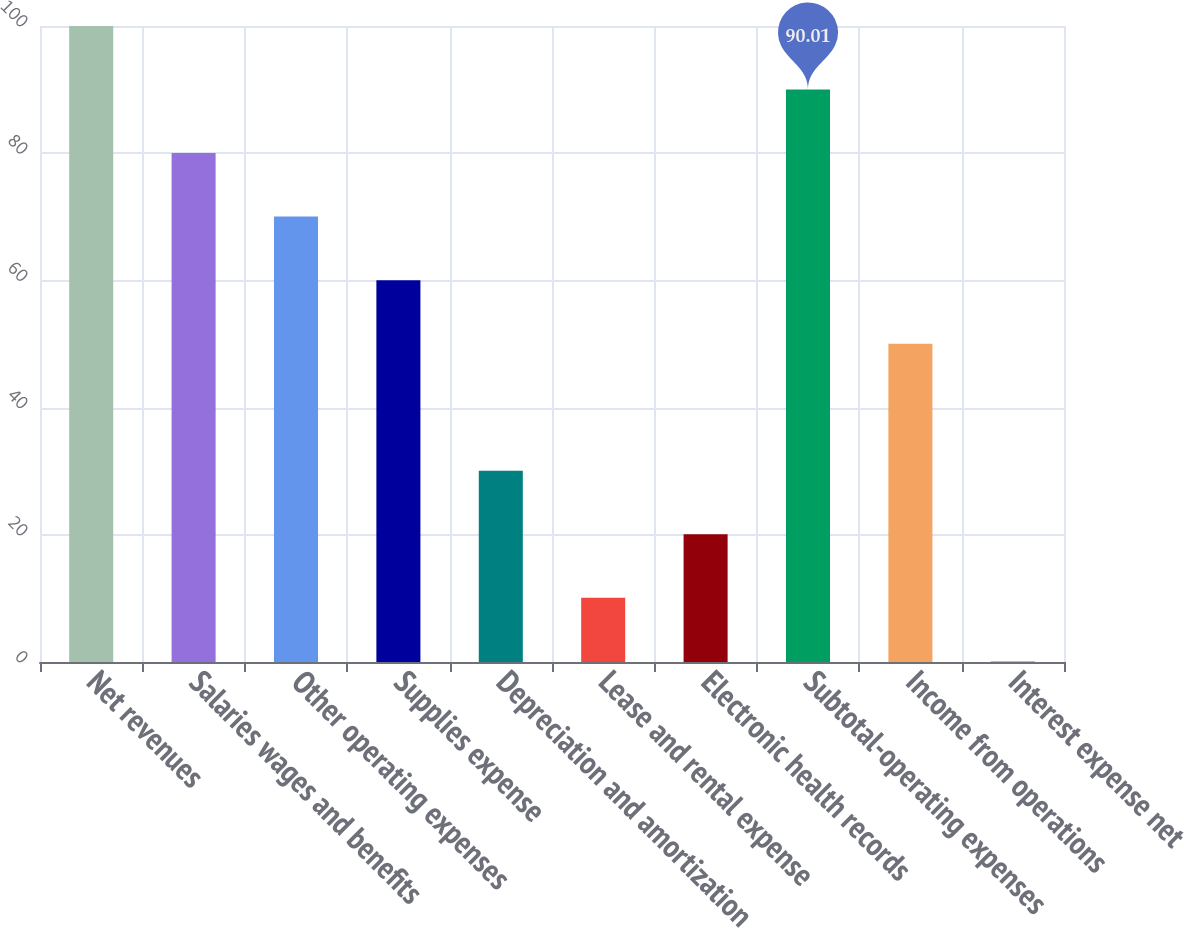Convert chart. <chart><loc_0><loc_0><loc_500><loc_500><bar_chart><fcel>Net revenues<fcel>Salaries wages and benefits<fcel>Other operating expenses<fcel>Supplies expense<fcel>Depreciation and amortization<fcel>Lease and rental expense<fcel>Electronic health records<fcel>Subtotal-operating expenses<fcel>Income from operations<fcel>Interest expense net<nl><fcel>100<fcel>80.02<fcel>70.03<fcel>60.04<fcel>30.07<fcel>10.09<fcel>20.08<fcel>90.01<fcel>50.05<fcel>0.1<nl></chart> 